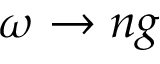Convert formula to latex. <formula><loc_0><loc_0><loc_500><loc_500>\omega \to n g</formula> 